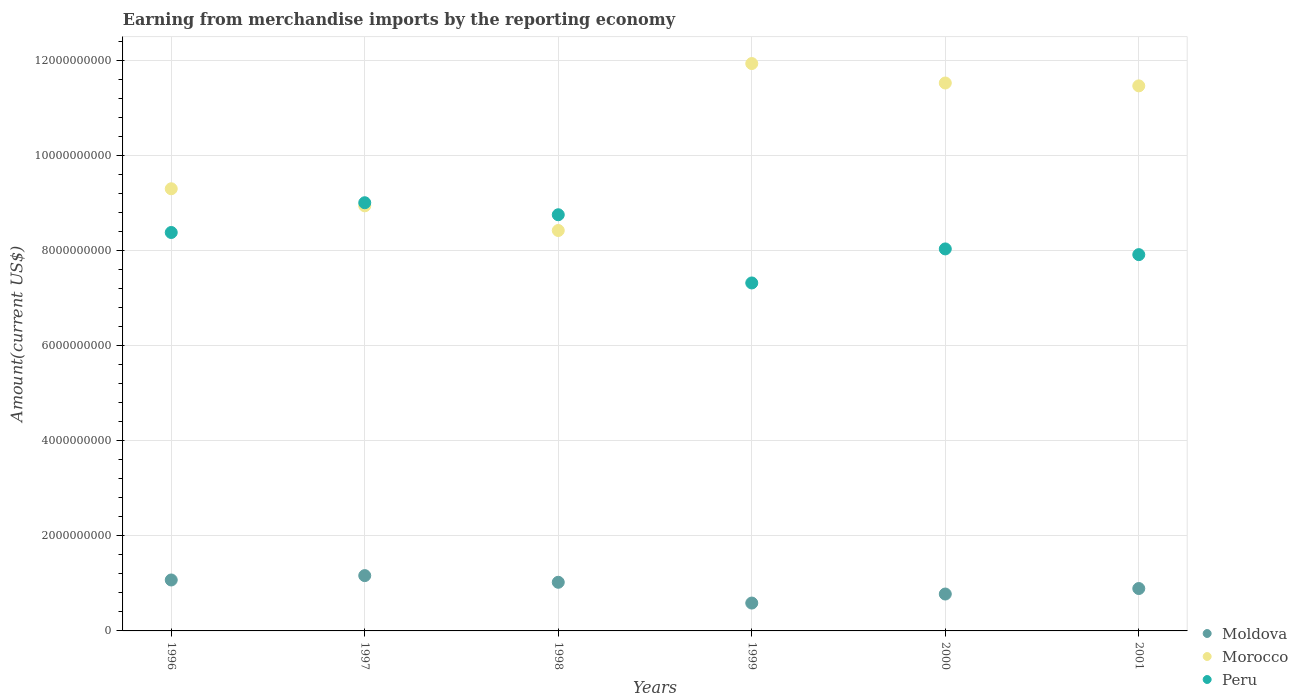Is the number of dotlines equal to the number of legend labels?
Your response must be concise. Yes. What is the amount earned from merchandise imports in Moldova in 2000?
Keep it short and to the point. 7.76e+08. Across all years, what is the maximum amount earned from merchandise imports in Moldova?
Offer a terse response. 1.16e+09. Across all years, what is the minimum amount earned from merchandise imports in Morocco?
Provide a short and direct response. 8.43e+09. In which year was the amount earned from merchandise imports in Peru maximum?
Provide a short and direct response. 1997. In which year was the amount earned from merchandise imports in Moldova minimum?
Your answer should be compact. 1999. What is the total amount earned from merchandise imports in Moldova in the graph?
Make the answer very short. 5.52e+09. What is the difference between the amount earned from merchandise imports in Morocco in 1999 and that in 2000?
Offer a terse response. 4.09e+08. What is the difference between the amount earned from merchandise imports in Peru in 1997 and the amount earned from merchandise imports in Moldova in 1999?
Your answer should be very brief. 8.43e+09. What is the average amount earned from merchandise imports in Moldova per year?
Give a very brief answer. 9.19e+08. In the year 1996, what is the difference between the amount earned from merchandise imports in Moldova and amount earned from merchandise imports in Peru?
Provide a succinct answer. -7.31e+09. What is the ratio of the amount earned from merchandise imports in Moldova in 1997 to that in 1999?
Your response must be concise. 1.99. Is the difference between the amount earned from merchandise imports in Moldova in 1996 and 1999 greater than the difference between the amount earned from merchandise imports in Peru in 1996 and 1999?
Keep it short and to the point. No. What is the difference between the highest and the second highest amount earned from merchandise imports in Morocco?
Offer a terse response. 4.09e+08. What is the difference between the highest and the lowest amount earned from merchandise imports in Morocco?
Ensure brevity in your answer.  3.51e+09. Is the amount earned from merchandise imports in Moldova strictly greater than the amount earned from merchandise imports in Peru over the years?
Offer a very short reply. No. Is the amount earned from merchandise imports in Peru strictly less than the amount earned from merchandise imports in Moldova over the years?
Give a very brief answer. No. How many dotlines are there?
Your response must be concise. 3. How many years are there in the graph?
Offer a very short reply. 6. Are the values on the major ticks of Y-axis written in scientific E-notation?
Provide a succinct answer. No. Does the graph contain any zero values?
Offer a very short reply. No. Does the graph contain grids?
Give a very brief answer. Yes. Where does the legend appear in the graph?
Give a very brief answer. Bottom right. How many legend labels are there?
Make the answer very short. 3. What is the title of the graph?
Your answer should be very brief. Earning from merchandise imports by the reporting economy. Does "Marshall Islands" appear as one of the legend labels in the graph?
Your answer should be compact. No. What is the label or title of the X-axis?
Make the answer very short. Years. What is the label or title of the Y-axis?
Make the answer very short. Amount(current US$). What is the Amount(current US$) of Moldova in 1996?
Your response must be concise. 1.07e+09. What is the Amount(current US$) of Morocco in 1996?
Provide a succinct answer. 9.31e+09. What is the Amount(current US$) of Peru in 1996?
Keep it short and to the point. 8.39e+09. What is the Amount(current US$) of Moldova in 1997?
Keep it short and to the point. 1.16e+09. What is the Amount(current US$) of Morocco in 1997?
Your answer should be compact. 8.95e+09. What is the Amount(current US$) in Peru in 1997?
Ensure brevity in your answer.  9.01e+09. What is the Amount(current US$) in Moldova in 1998?
Keep it short and to the point. 1.02e+09. What is the Amount(current US$) in Morocco in 1998?
Provide a succinct answer. 8.43e+09. What is the Amount(current US$) in Peru in 1998?
Ensure brevity in your answer.  8.76e+09. What is the Amount(current US$) in Moldova in 1999?
Make the answer very short. 5.86e+08. What is the Amount(current US$) of Morocco in 1999?
Provide a succinct answer. 1.19e+1. What is the Amount(current US$) in Peru in 1999?
Your response must be concise. 7.32e+09. What is the Amount(current US$) in Moldova in 2000?
Provide a short and direct response. 7.76e+08. What is the Amount(current US$) in Morocco in 2000?
Keep it short and to the point. 1.15e+1. What is the Amount(current US$) in Peru in 2000?
Your answer should be compact. 8.04e+09. What is the Amount(current US$) of Moldova in 2001?
Give a very brief answer. 8.92e+08. What is the Amount(current US$) of Morocco in 2001?
Make the answer very short. 1.15e+1. What is the Amount(current US$) of Peru in 2001?
Make the answer very short. 7.92e+09. Across all years, what is the maximum Amount(current US$) of Moldova?
Provide a short and direct response. 1.16e+09. Across all years, what is the maximum Amount(current US$) of Morocco?
Make the answer very short. 1.19e+1. Across all years, what is the maximum Amount(current US$) of Peru?
Ensure brevity in your answer.  9.01e+09. Across all years, what is the minimum Amount(current US$) of Moldova?
Offer a terse response. 5.86e+08. Across all years, what is the minimum Amount(current US$) of Morocco?
Offer a terse response. 8.43e+09. Across all years, what is the minimum Amount(current US$) in Peru?
Provide a succinct answer. 7.32e+09. What is the total Amount(current US$) in Moldova in the graph?
Provide a short and direct response. 5.52e+09. What is the total Amount(current US$) of Morocco in the graph?
Provide a succinct answer. 6.16e+1. What is the total Amount(current US$) in Peru in the graph?
Your response must be concise. 4.94e+1. What is the difference between the Amount(current US$) in Moldova in 1996 and that in 1997?
Give a very brief answer. -9.18e+07. What is the difference between the Amount(current US$) of Morocco in 1996 and that in 1997?
Provide a short and direct response. 3.59e+08. What is the difference between the Amount(current US$) of Peru in 1996 and that in 1997?
Offer a terse response. -6.26e+08. What is the difference between the Amount(current US$) of Moldova in 1996 and that in 1998?
Offer a terse response. 4.85e+07. What is the difference between the Amount(current US$) in Morocco in 1996 and that in 1998?
Provide a succinct answer. 8.78e+08. What is the difference between the Amount(current US$) in Peru in 1996 and that in 1998?
Make the answer very short. -3.73e+08. What is the difference between the Amount(current US$) in Moldova in 1996 and that in 1999?
Offer a very short reply. 4.86e+08. What is the difference between the Amount(current US$) in Morocco in 1996 and that in 1999?
Keep it short and to the point. -2.64e+09. What is the difference between the Amount(current US$) of Peru in 1996 and that in 1999?
Offer a terse response. 1.06e+09. What is the difference between the Amount(current US$) of Moldova in 1996 and that in 2000?
Offer a terse response. 2.96e+08. What is the difference between the Amount(current US$) in Morocco in 1996 and that in 2000?
Offer a very short reply. -2.23e+09. What is the difference between the Amount(current US$) in Peru in 1996 and that in 2000?
Your response must be concise. 3.46e+08. What is the difference between the Amount(current US$) in Moldova in 1996 and that in 2001?
Give a very brief answer. 1.80e+08. What is the difference between the Amount(current US$) of Morocco in 1996 and that in 2001?
Keep it short and to the point. -2.17e+09. What is the difference between the Amount(current US$) in Peru in 1996 and that in 2001?
Offer a very short reply. 4.66e+08. What is the difference between the Amount(current US$) in Moldova in 1997 and that in 1998?
Offer a very short reply. 1.40e+08. What is the difference between the Amount(current US$) of Morocco in 1997 and that in 1998?
Your response must be concise. 5.19e+08. What is the difference between the Amount(current US$) of Peru in 1997 and that in 1998?
Your response must be concise. 2.53e+08. What is the difference between the Amount(current US$) of Moldova in 1997 and that in 1999?
Offer a terse response. 5.78e+08. What is the difference between the Amount(current US$) in Morocco in 1997 and that in 1999?
Your answer should be compact. -2.99e+09. What is the difference between the Amount(current US$) in Peru in 1997 and that in 1999?
Offer a terse response. 1.69e+09. What is the difference between the Amount(current US$) of Moldova in 1997 and that in 2000?
Offer a very short reply. 3.88e+08. What is the difference between the Amount(current US$) in Morocco in 1997 and that in 2000?
Your response must be concise. -2.58e+09. What is the difference between the Amount(current US$) in Peru in 1997 and that in 2000?
Your answer should be very brief. 9.72e+08. What is the difference between the Amount(current US$) in Moldova in 1997 and that in 2001?
Provide a short and direct response. 2.72e+08. What is the difference between the Amount(current US$) in Morocco in 1997 and that in 2001?
Offer a very short reply. -2.52e+09. What is the difference between the Amount(current US$) in Peru in 1997 and that in 2001?
Offer a very short reply. 1.09e+09. What is the difference between the Amount(current US$) in Moldova in 1998 and that in 1999?
Your response must be concise. 4.37e+08. What is the difference between the Amount(current US$) in Morocco in 1998 and that in 1999?
Your answer should be very brief. -3.51e+09. What is the difference between the Amount(current US$) of Peru in 1998 and that in 1999?
Offer a terse response. 1.44e+09. What is the difference between the Amount(current US$) of Moldova in 1998 and that in 2000?
Your answer should be compact. 2.47e+08. What is the difference between the Amount(current US$) in Morocco in 1998 and that in 2000?
Make the answer very short. -3.10e+09. What is the difference between the Amount(current US$) of Peru in 1998 and that in 2000?
Give a very brief answer. 7.19e+08. What is the difference between the Amount(current US$) of Moldova in 1998 and that in 2001?
Offer a terse response. 1.31e+08. What is the difference between the Amount(current US$) in Morocco in 1998 and that in 2001?
Your answer should be very brief. -3.04e+09. What is the difference between the Amount(current US$) in Peru in 1998 and that in 2001?
Your answer should be compact. 8.39e+08. What is the difference between the Amount(current US$) of Moldova in 1999 and that in 2000?
Offer a very short reply. -1.90e+08. What is the difference between the Amount(current US$) in Morocco in 1999 and that in 2000?
Keep it short and to the point. 4.09e+08. What is the difference between the Amount(current US$) of Peru in 1999 and that in 2000?
Your answer should be very brief. -7.16e+08. What is the difference between the Amount(current US$) in Moldova in 1999 and that in 2001?
Keep it short and to the point. -3.06e+08. What is the difference between the Amount(current US$) in Morocco in 1999 and that in 2001?
Your answer should be compact. 4.70e+08. What is the difference between the Amount(current US$) in Peru in 1999 and that in 2001?
Offer a very short reply. -5.96e+08. What is the difference between the Amount(current US$) in Moldova in 2000 and that in 2001?
Make the answer very short. -1.16e+08. What is the difference between the Amount(current US$) in Morocco in 2000 and that in 2001?
Make the answer very short. 6.01e+07. What is the difference between the Amount(current US$) in Peru in 2000 and that in 2001?
Offer a very short reply. 1.20e+08. What is the difference between the Amount(current US$) of Moldova in 1996 and the Amount(current US$) of Morocco in 1997?
Give a very brief answer. -7.87e+09. What is the difference between the Amount(current US$) in Moldova in 1996 and the Amount(current US$) in Peru in 1997?
Give a very brief answer. -7.94e+09. What is the difference between the Amount(current US$) in Morocco in 1996 and the Amount(current US$) in Peru in 1997?
Make the answer very short. 2.94e+08. What is the difference between the Amount(current US$) in Moldova in 1996 and the Amount(current US$) in Morocco in 1998?
Your response must be concise. -7.35e+09. What is the difference between the Amount(current US$) in Moldova in 1996 and the Amount(current US$) in Peru in 1998?
Your answer should be compact. -7.69e+09. What is the difference between the Amount(current US$) of Morocco in 1996 and the Amount(current US$) of Peru in 1998?
Make the answer very short. 5.47e+08. What is the difference between the Amount(current US$) of Moldova in 1996 and the Amount(current US$) of Morocco in 1999?
Your response must be concise. -1.09e+1. What is the difference between the Amount(current US$) of Moldova in 1996 and the Amount(current US$) of Peru in 1999?
Offer a very short reply. -6.25e+09. What is the difference between the Amount(current US$) in Morocco in 1996 and the Amount(current US$) in Peru in 1999?
Your answer should be very brief. 1.98e+09. What is the difference between the Amount(current US$) of Moldova in 1996 and the Amount(current US$) of Morocco in 2000?
Keep it short and to the point. -1.05e+1. What is the difference between the Amount(current US$) in Moldova in 1996 and the Amount(current US$) in Peru in 2000?
Offer a very short reply. -6.97e+09. What is the difference between the Amount(current US$) in Morocco in 1996 and the Amount(current US$) in Peru in 2000?
Offer a terse response. 1.27e+09. What is the difference between the Amount(current US$) in Moldova in 1996 and the Amount(current US$) in Morocco in 2001?
Ensure brevity in your answer.  -1.04e+1. What is the difference between the Amount(current US$) of Moldova in 1996 and the Amount(current US$) of Peru in 2001?
Your response must be concise. -6.85e+09. What is the difference between the Amount(current US$) in Morocco in 1996 and the Amount(current US$) in Peru in 2001?
Provide a succinct answer. 1.39e+09. What is the difference between the Amount(current US$) of Moldova in 1997 and the Amount(current US$) of Morocco in 1998?
Ensure brevity in your answer.  -7.26e+09. What is the difference between the Amount(current US$) of Moldova in 1997 and the Amount(current US$) of Peru in 1998?
Provide a succinct answer. -7.59e+09. What is the difference between the Amount(current US$) of Morocco in 1997 and the Amount(current US$) of Peru in 1998?
Keep it short and to the point. 1.88e+08. What is the difference between the Amount(current US$) in Moldova in 1997 and the Amount(current US$) in Morocco in 1999?
Your response must be concise. -1.08e+1. What is the difference between the Amount(current US$) of Moldova in 1997 and the Amount(current US$) of Peru in 1999?
Provide a succinct answer. -6.16e+09. What is the difference between the Amount(current US$) of Morocco in 1997 and the Amount(current US$) of Peru in 1999?
Ensure brevity in your answer.  1.62e+09. What is the difference between the Amount(current US$) of Moldova in 1997 and the Amount(current US$) of Morocco in 2000?
Offer a very short reply. -1.04e+1. What is the difference between the Amount(current US$) in Moldova in 1997 and the Amount(current US$) in Peru in 2000?
Provide a succinct answer. -6.88e+09. What is the difference between the Amount(current US$) of Morocco in 1997 and the Amount(current US$) of Peru in 2000?
Provide a short and direct response. 9.07e+08. What is the difference between the Amount(current US$) of Moldova in 1997 and the Amount(current US$) of Morocco in 2001?
Offer a very short reply. -1.03e+1. What is the difference between the Amount(current US$) of Moldova in 1997 and the Amount(current US$) of Peru in 2001?
Your answer should be compact. -6.76e+09. What is the difference between the Amount(current US$) in Morocco in 1997 and the Amount(current US$) in Peru in 2001?
Make the answer very short. 1.03e+09. What is the difference between the Amount(current US$) in Moldova in 1998 and the Amount(current US$) in Morocco in 1999?
Your answer should be compact. -1.09e+1. What is the difference between the Amount(current US$) in Moldova in 1998 and the Amount(current US$) in Peru in 1999?
Ensure brevity in your answer.  -6.30e+09. What is the difference between the Amount(current US$) of Morocco in 1998 and the Amount(current US$) of Peru in 1999?
Offer a terse response. 1.10e+09. What is the difference between the Amount(current US$) of Moldova in 1998 and the Amount(current US$) of Morocco in 2000?
Make the answer very short. -1.05e+1. What is the difference between the Amount(current US$) of Moldova in 1998 and the Amount(current US$) of Peru in 2000?
Offer a very short reply. -7.02e+09. What is the difference between the Amount(current US$) in Morocco in 1998 and the Amount(current US$) in Peru in 2000?
Give a very brief answer. 3.88e+08. What is the difference between the Amount(current US$) in Moldova in 1998 and the Amount(current US$) in Morocco in 2001?
Make the answer very short. -1.04e+1. What is the difference between the Amount(current US$) of Moldova in 1998 and the Amount(current US$) of Peru in 2001?
Your answer should be very brief. -6.90e+09. What is the difference between the Amount(current US$) of Morocco in 1998 and the Amount(current US$) of Peru in 2001?
Give a very brief answer. 5.08e+08. What is the difference between the Amount(current US$) of Moldova in 1999 and the Amount(current US$) of Morocco in 2000?
Offer a very short reply. -1.09e+1. What is the difference between the Amount(current US$) of Moldova in 1999 and the Amount(current US$) of Peru in 2000?
Keep it short and to the point. -7.45e+09. What is the difference between the Amount(current US$) in Morocco in 1999 and the Amount(current US$) in Peru in 2000?
Your response must be concise. 3.90e+09. What is the difference between the Amount(current US$) in Moldova in 1999 and the Amount(current US$) in Morocco in 2001?
Your answer should be compact. -1.09e+1. What is the difference between the Amount(current US$) of Moldova in 1999 and the Amount(current US$) of Peru in 2001?
Your answer should be compact. -7.33e+09. What is the difference between the Amount(current US$) in Morocco in 1999 and the Amount(current US$) in Peru in 2001?
Your response must be concise. 4.02e+09. What is the difference between the Amount(current US$) in Moldova in 2000 and the Amount(current US$) in Morocco in 2001?
Offer a very short reply. -1.07e+1. What is the difference between the Amount(current US$) of Moldova in 2000 and the Amount(current US$) of Peru in 2001?
Offer a terse response. -7.14e+09. What is the difference between the Amount(current US$) of Morocco in 2000 and the Amount(current US$) of Peru in 2001?
Your response must be concise. 3.61e+09. What is the average Amount(current US$) in Moldova per year?
Provide a short and direct response. 9.19e+08. What is the average Amount(current US$) of Morocco per year?
Your answer should be compact. 1.03e+1. What is the average Amount(current US$) in Peru per year?
Ensure brevity in your answer.  8.24e+09. In the year 1996, what is the difference between the Amount(current US$) in Moldova and Amount(current US$) in Morocco?
Your answer should be compact. -8.23e+09. In the year 1996, what is the difference between the Amount(current US$) in Moldova and Amount(current US$) in Peru?
Your answer should be compact. -7.31e+09. In the year 1996, what is the difference between the Amount(current US$) in Morocco and Amount(current US$) in Peru?
Your answer should be very brief. 9.20e+08. In the year 1997, what is the difference between the Amount(current US$) of Moldova and Amount(current US$) of Morocco?
Your response must be concise. -7.78e+09. In the year 1997, what is the difference between the Amount(current US$) of Moldova and Amount(current US$) of Peru?
Give a very brief answer. -7.85e+09. In the year 1997, what is the difference between the Amount(current US$) of Morocco and Amount(current US$) of Peru?
Keep it short and to the point. -6.51e+07. In the year 1998, what is the difference between the Amount(current US$) of Moldova and Amount(current US$) of Morocco?
Provide a succinct answer. -7.40e+09. In the year 1998, what is the difference between the Amount(current US$) of Moldova and Amount(current US$) of Peru?
Provide a short and direct response. -7.73e+09. In the year 1998, what is the difference between the Amount(current US$) of Morocco and Amount(current US$) of Peru?
Give a very brief answer. -3.31e+08. In the year 1999, what is the difference between the Amount(current US$) in Moldova and Amount(current US$) in Morocco?
Your response must be concise. -1.14e+1. In the year 1999, what is the difference between the Amount(current US$) in Moldova and Amount(current US$) in Peru?
Your answer should be compact. -6.74e+09. In the year 1999, what is the difference between the Amount(current US$) of Morocco and Amount(current US$) of Peru?
Your answer should be very brief. 4.62e+09. In the year 2000, what is the difference between the Amount(current US$) in Moldova and Amount(current US$) in Morocco?
Your response must be concise. -1.08e+1. In the year 2000, what is the difference between the Amount(current US$) of Moldova and Amount(current US$) of Peru?
Ensure brevity in your answer.  -7.26e+09. In the year 2000, what is the difference between the Amount(current US$) of Morocco and Amount(current US$) of Peru?
Your answer should be very brief. 3.49e+09. In the year 2001, what is the difference between the Amount(current US$) in Moldova and Amount(current US$) in Morocco?
Offer a very short reply. -1.06e+1. In the year 2001, what is the difference between the Amount(current US$) of Moldova and Amount(current US$) of Peru?
Offer a very short reply. -7.03e+09. In the year 2001, what is the difference between the Amount(current US$) in Morocco and Amount(current US$) in Peru?
Make the answer very short. 3.55e+09. What is the ratio of the Amount(current US$) of Moldova in 1996 to that in 1997?
Provide a short and direct response. 0.92. What is the ratio of the Amount(current US$) in Morocco in 1996 to that in 1997?
Ensure brevity in your answer.  1.04. What is the ratio of the Amount(current US$) in Peru in 1996 to that in 1997?
Your response must be concise. 0.93. What is the ratio of the Amount(current US$) in Moldova in 1996 to that in 1998?
Provide a succinct answer. 1.05. What is the ratio of the Amount(current US$) in Morocco in 1996 to that in 1998?
Provide a short and direct response. 1.1. What is the ratio of the Amount(current US$) of Peru in 1996 to that in 1998?
Your answer should be very brief. 0.96. What is the ratio of the Amount(current US$) of Moldova in 1996 to that in 1999?
Ensure brevity in your answer.  1.83. What is the ratio of the Amount(current US$) in Morocco in 1996 to that in 1999?
Offer a very short reply. 0.78. What is the ratio of the Amount(current US$) of Peru in 1996 to that in 1999?
Your response must be concise. 1.15. What is the ratio of the Amount(current US$) in Moldova in 1996 to that in 2000?
Your answer should be very brief. 1.38. What is the ratio of the Amount(current US$) in Morocco in 1996 to that in 2000?
Provide a succinct answer. 0.81. What is the ratio of the Amount(current US$) in Peru in 1996 to that in 2000?
Your response must be concise. 1.04. What is the ratio of the Amount(current US$) in Moldova in 1996 to that in 2001?
Give a very brief answer. 1.2. What is the ratio of the Amount(current US$) of Morocco in 1996 to that in 2001?
Your answer should be compact. 0.81. What is the ratio of the Amount(current US$) of Peru in 1996 to that in 2001?
Offer a very short reply. 1.06. What is the ratio of the Amount(current US$) in Moldova in 1997 to that in 1998?
Make the answer very short. 1.14. What is the ratio of the Amount(current US$) of Morocco in 1997 to that in 1998?
Keep it short and to the point. 1.06. What is the ratio of the Amount(current US$) of Peru in 1997 to that in 1998?
Your answer should be compact. 1.03. What is the ratio of the Amount(current US$) of Moldova in 1997 to that in 1999?
Provide a short and direct response. 1.99. What is the ratio of the Amount(current US$) of Morocco in 1997 to that in 1999?
Your answer should be very brief. 0.75. What is the ratio of the Amount(current US$) in Peru in 1997 to that in 1999?
Your answer should be very brief. 1.23. What is the ratio of the Amount(current US$) in Moldova in 1997 to that in 2000?
Your answer should be very brief. 1.5. What is the ratio of the Amount(current US$) in Morocco in 1997 to that in 2000?
Your answer should be very brief. 0.78. What is the ratio of the Amount(current US$) in Peru in 1997 to that in 2000?
Your answer should be compact. 1.12. What is the ratio of the Amount(current US$) in Moldova in 1997 to that in 2001?
Keep it short and to the point. 1.3. What is the ratio of the Amount(current US$) of Morocco in 1997 to that in 2001?
Offer a very short reply. 0.78. What is the ratio of the Amount(current US$) of Peru in 1997 to that in 2001?
Make the answer very short. 1.14. What is the ratio of the Amount(current US$) in Moldova in 1998 to that in 1999?
Provide a succinct answer. 1.75. What is the ratio of the Amount(current US$) in Morocco in 1998 to that in 1999?
Ensure brevity in your answer.  0.71. What is the ratio of the Amount(current US$) of Peru in 1998 to that in 1999?
Keep it short and to the point. 1.2. What is the ratio of the Amount(current US$) of Moldova in 1998 to that in 2000?
Your answer should be compact. 1.32. What is the ratio of the Amount(current US$) in Morocco in 1998 to that in 2000?
Provide a short and direct response. 0.73. What is the ratio of the Amount(current US$) in Peru in 1998 to that in 2000?
Offer a very short reply. 1.09. What is the ratio of the Amount(current US$) in Moldova in 1998 to that in 2001?
Provide a short and direct response. 1.15. What is the ratio of the Amount(current US$) in Morocco in 1998 to that in 2001?
Keep it short and to the point. 0.73. What is the ratio of the Amount(current US$) in Peru in 1998 to that in 2001?
Your answer should be compact. 1.11. What is the ratio of the Amount(current US$) in Moldova in 1999 to that in 2000?
Make the answer very short. 0.76. What is the ratio of the Amount(current US$) in Morocco in 1999 to that in 2000?
Your answer should be very brief. 1.04. What is the ratio of the Amount(current US$) of Peru in 1999 to that in 2000?
Your answer should be compact. 0.91. What is the ratio of the Amount(current US$) of Moldova in 1999 to that in 2001?
Your response must be concise. 0.66. What is the ratio of the Amount(current US$) in Morocco in 1999 to that in 2001?
Provide a succinct answer. 1.04. What is the ratio of the Amount(current US$) of Peru in 1999 to that in 2001?
Provide a succinct answer. 0.92. What is the ratio of the Amount(current US$) of Moldova in 2000 to that in 2001?
Provide a short and direct response. 0.87. What is the ratio of the Amount(current US$) of Morocco in 2000 to that in 2001?
Offer a very short reply. 1.01. What is the ratio of the Amount(current US$) of Peru in 2000 to that in 2001?
Ensure brevity in your answer.  1.02. What is the difference between the highest and the second highest Amount(current US$) in Moldova?
Offer a terse response. 9.18e+07. What is the difference between the highest and the second highest Amount(current US$) of Morocco?
Provide a succinct answer. 4.09e+08. What is the difference between the highest and the second highest Amount(current US$) in Peru?
Ensure brevity in your answer.  2.53e+08. What is the difference between the highest and the lowest Amount(current US$) in Moldova?
Provide a succinct answer. 5.78e+08. What is the difference between the highest and the lowest Amount(current US$) of Morocco?
Your answer should be very brief. 3.51e+09. What is the difference between the highest and the lowest Amount(current US$) of Peru?
Give a very brief answer. 1.69e+09. 